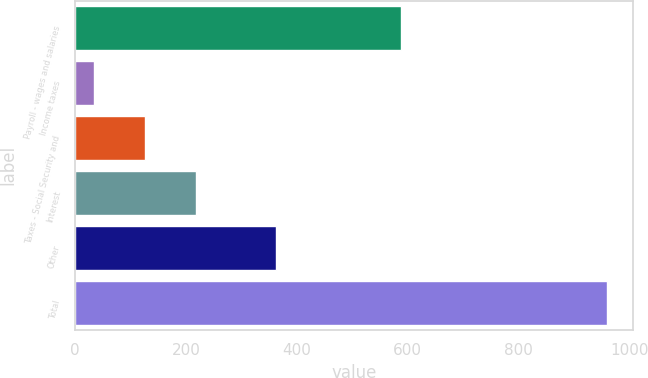<chart> <loc_0><loc_0><loc_500><loc_500><bar_chart><fcel>Payroll - wages and salaries<fcel>Income taxes<fcel>Taxes - Social Security and<fcel>Interest<fcel>Other<fcel>Total<nl><fcel>588<fcel>33<fcel>125.6<fcel>218.2<fcel>363<fcel>959<nl></chart> 